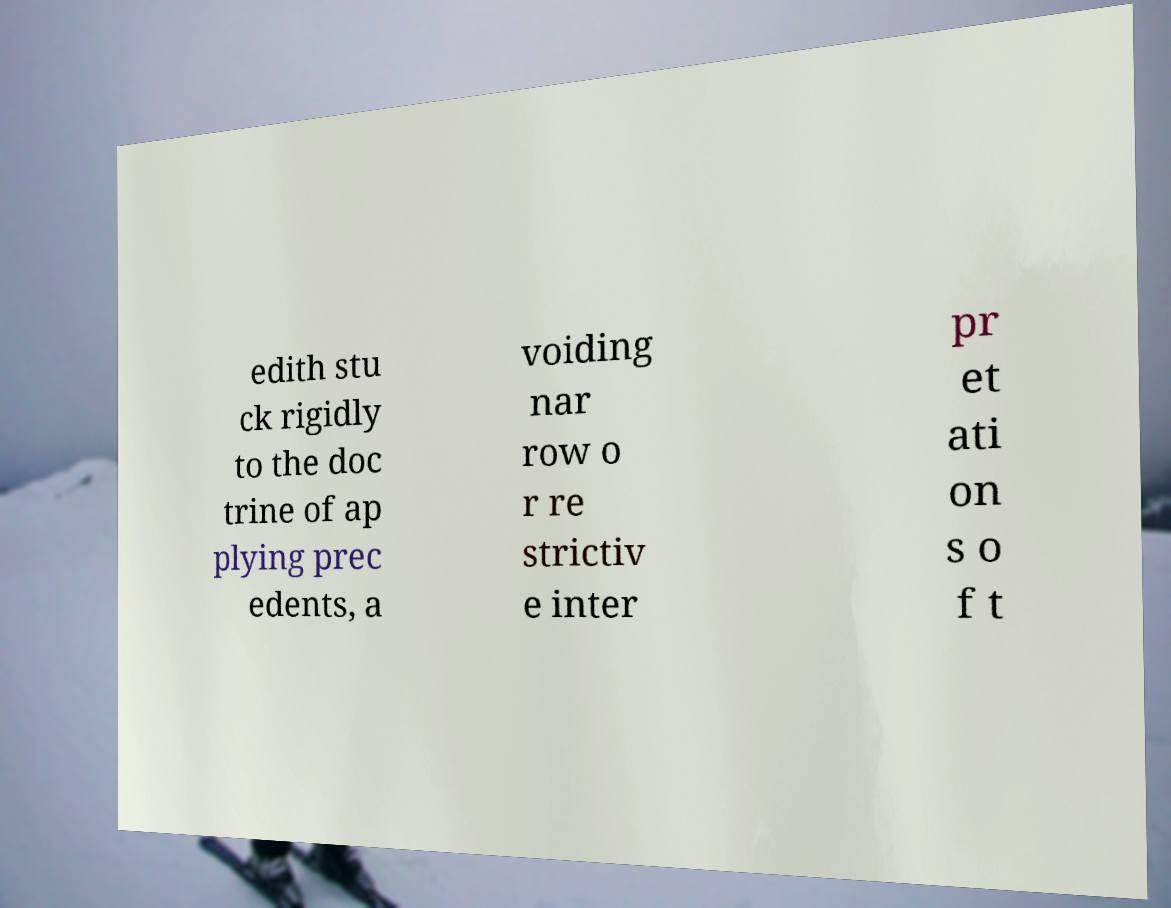For documentation purposes, I need the text within this image transcribed. Could you provide that? edith stu ck rigidly to the doc trine of ap plying prec edents, a voiding nar row o r re strictiv e inter pr et ati on s o f t 